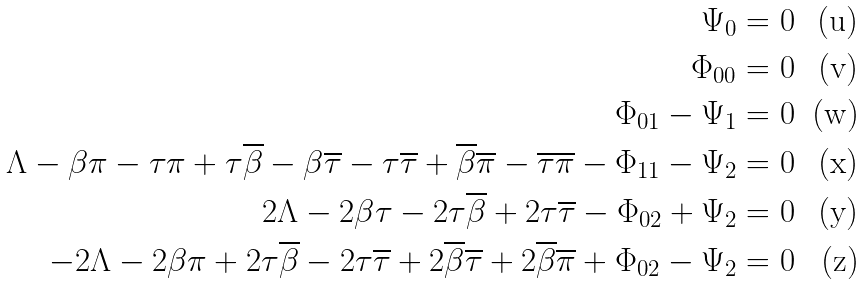<formula> <loc_0><loc_0><loc_500><loc_500>\Psi _ { 0 } & = 0 \\ \Phi _ { 0 0 } & = 0 \\ \Phi _ { 0 1 } - \Psi _ { 1 } & = 0 \\ \Lambda - \beta \pi - \tau \pi + \tau \overline { \beta } - \beta \overline { \tau } - \tau \overline { \tau } + \overline { \beta } \overline { \pi } - \overline { \tau } \overline { \pi } - \Phi _ { 1 1 } - \Psi _ { 2 } & = 0 \\ 2 \Lambda - 2 \beta \tau - 2 \tau \overline { \beta } + 2 \tau \overline { \tau } - \Phi _ { 0 2 } + \Psi _ { 2 } & = 0 \\ - 2 \Lambda - 2 \beta \pi + 2 \tau \overline { \beta } - 2 \tau \overline { \tau } + 2 \overline { \beta } \overline { \tau } + 2 \overline { \beta } \overline { \pi } + \Phi _ { 0 2 } - \Psi _ { 2 } & = 0</formula> 